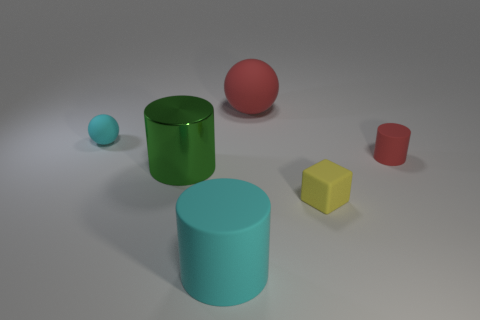Add 3 cyan cylinders. How many objects exist? 9 Subtract all spheres. How many objects are left? 4 Add 1 big red rubber spheres. How many big red rubber spheres exist? 2 Subtract 0 yellow cylinders. How many objects are left? 6 Subtract all large gray blocks. Subtract all red matte things. How many objects are left? 4 Add 5 red balls. How many red balls are left? 6 